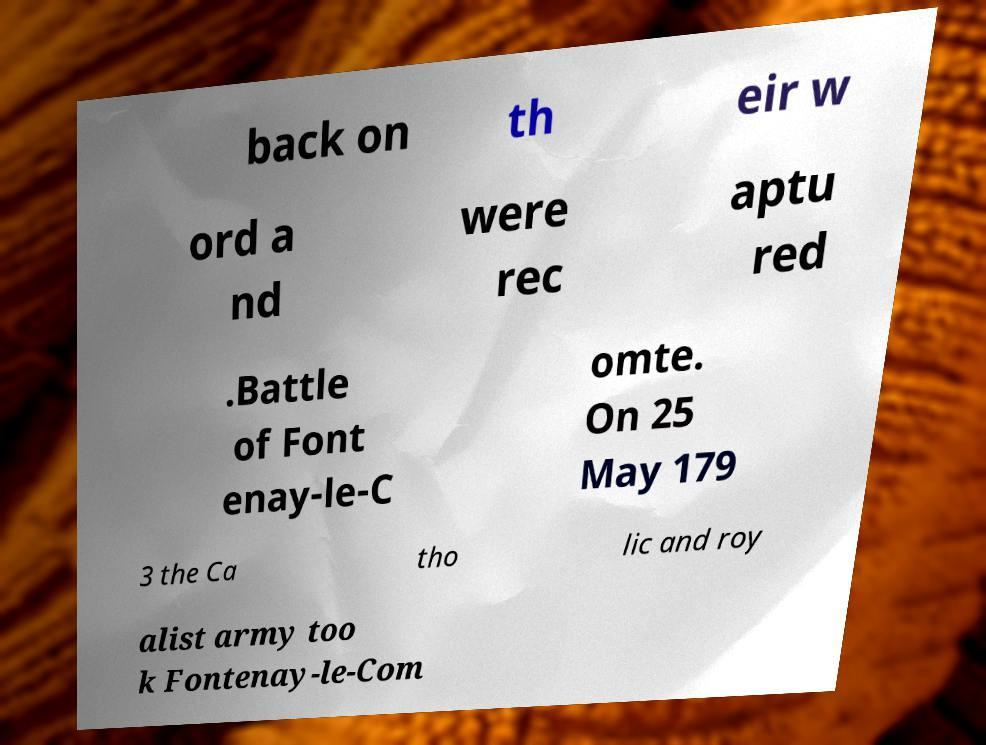Could you assist in decoding the text presented in this image and type it out clearly? back on th eir w ord a nd were rec aptu red .Battle of Font enay-le-C omte. On 25 May 179 3 the Ca tho lic and roy alist army too k Fontenay-le-Com 